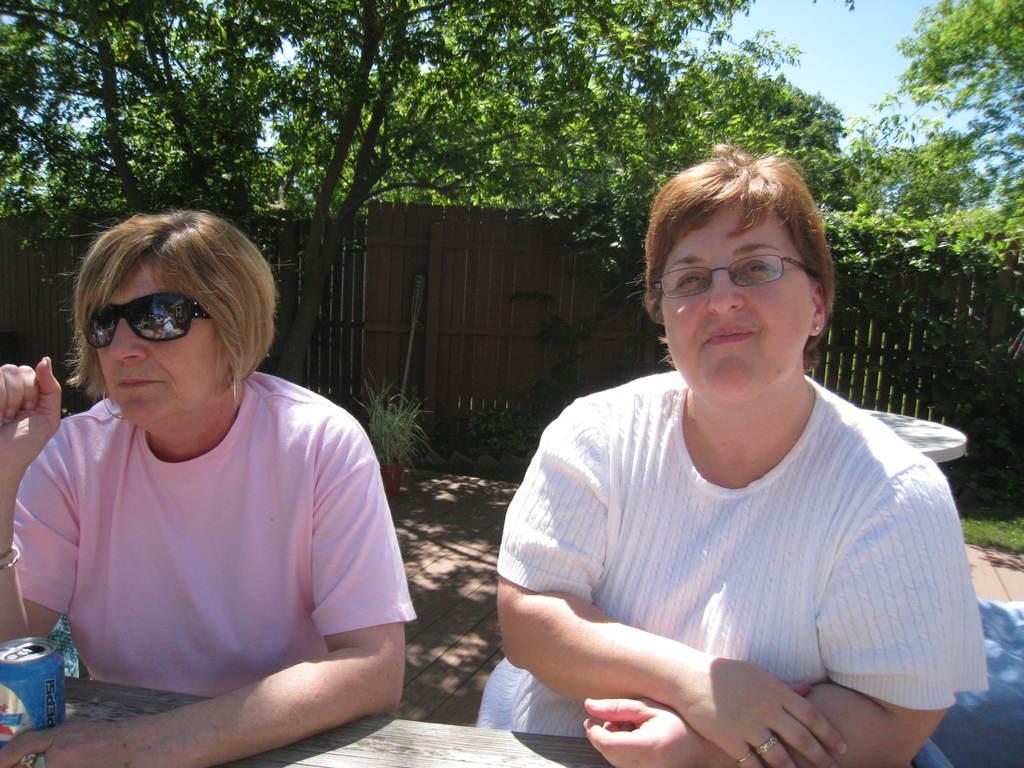How would you summarize this image in a sentence or two? In this picture we can see two women sitting, tin on a table, house plant on the ground, wall, trees and in the background we can see the sky. 